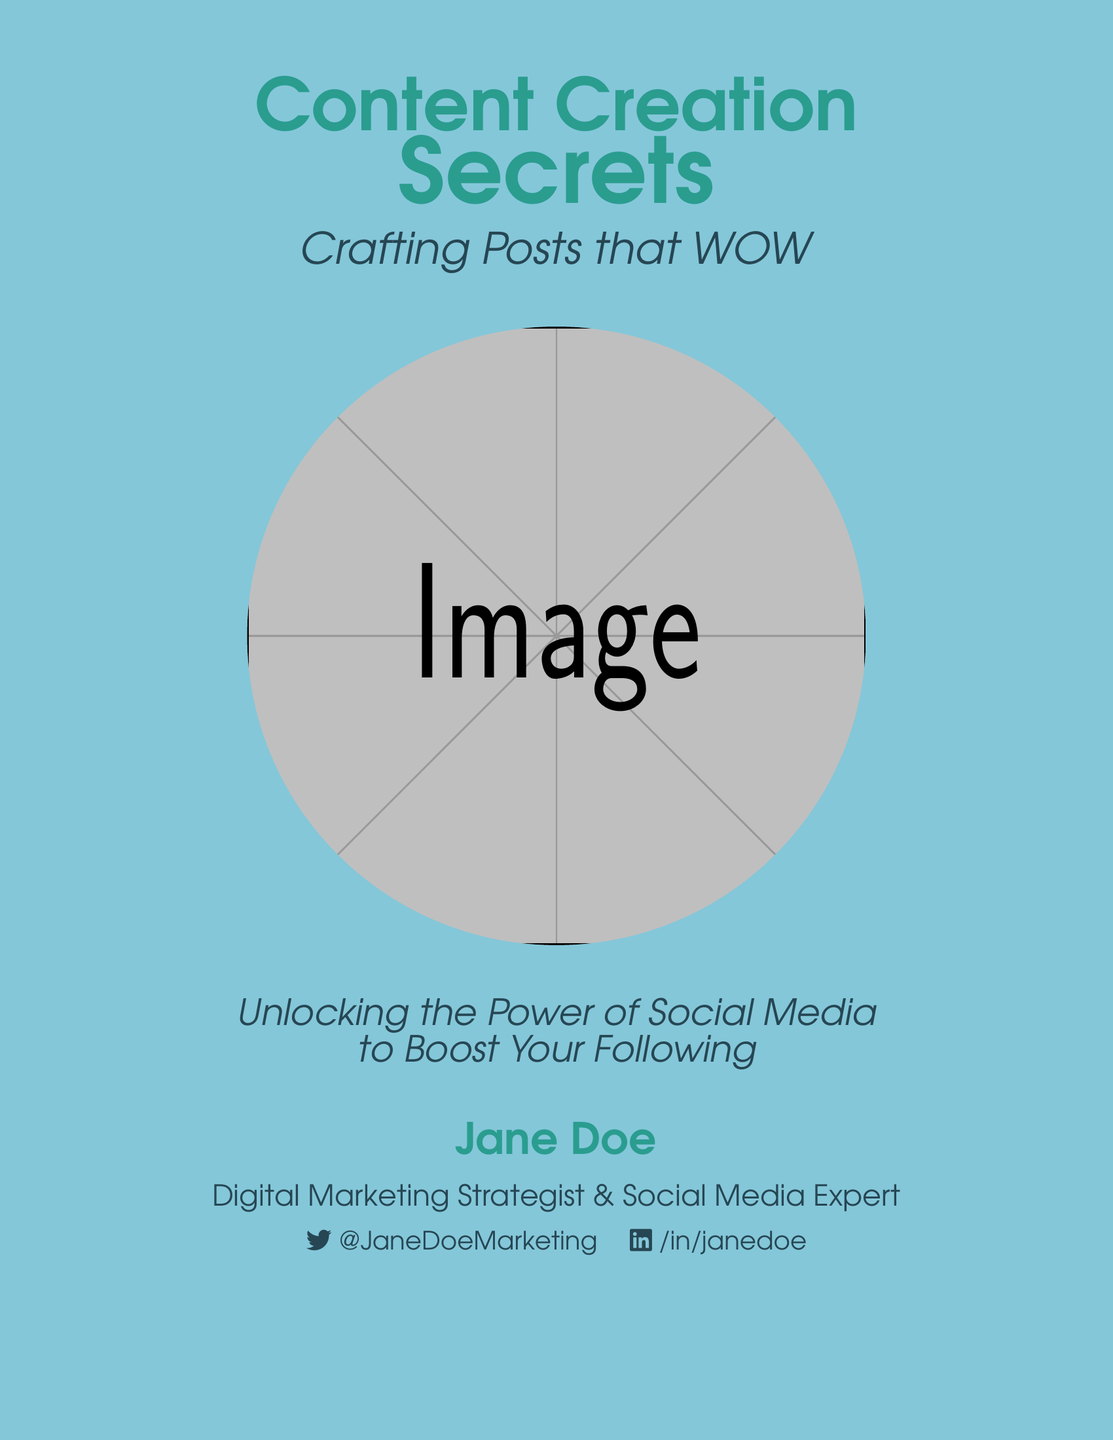What is the title of the book? The title is prominently displayed on the cover in a large font.
Answer: Content Creation Secrets Who is the author of the book? The author's name appears at the bottom of the cover.
Answer: Jane Doe What is the subtitle of the book? The subtitle is located below the title and emphasizes the book's focus.
Answer: Crafting Posts that WOW What is the author's profession? The author's profession is mentioned below their name on the cover.
Answer: Digital Marketing Strategist & Social Media Expert What color is the title text? The title text color can be seen clearly on the document.
Answer: Title color is teal (2A9D8F) What symbols are incorporated into the lightbulb design? The lightbulb design features a composite of various social media symbols.
Answer: Social media symbols How many elements are used to create the lightbulb in the design? The composition of the design uses a variety of symbols to form one cohesive shape.
Answer: Multiple elements What aspect of social media does the book focus on? The focus is evident from the subtitle and other text on the cover.
Answer: Boosting following 